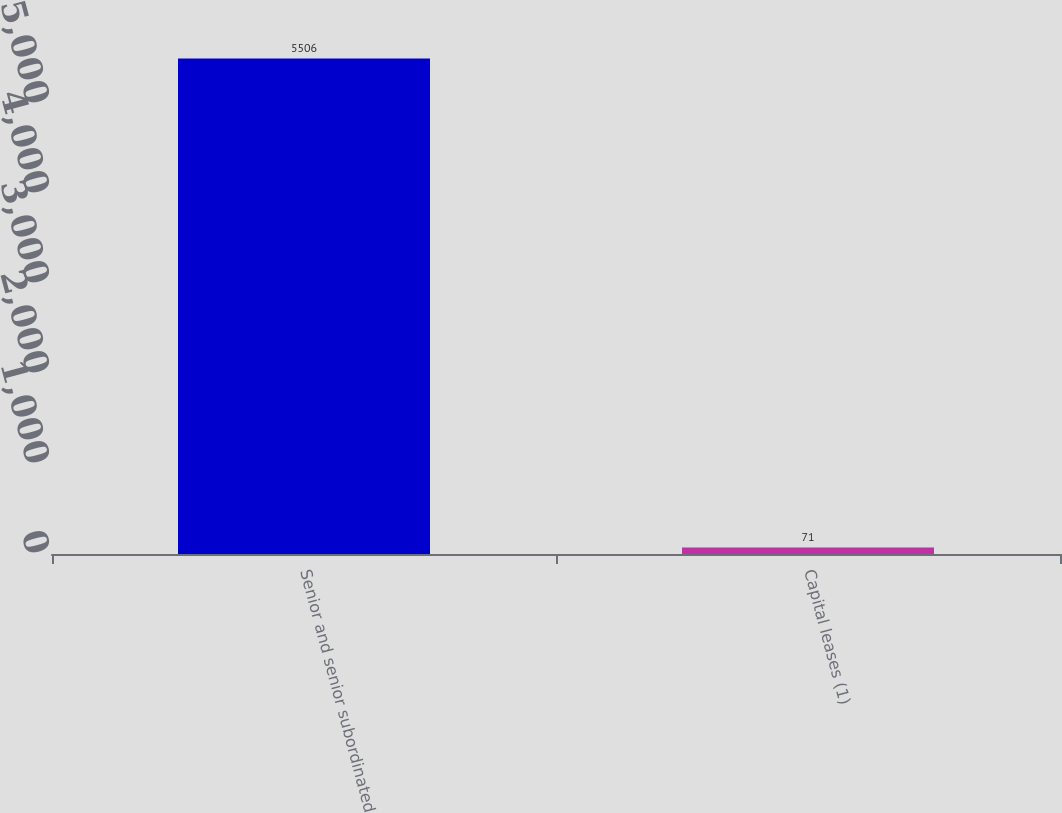<chart> <loc_0><loc_0><loc_500><loc_500><bar_chart><fcel>Senior and senior subordinated<fcel>Capital leases (1)<nl><fcel>5506<fcel>71<nl></chart> 